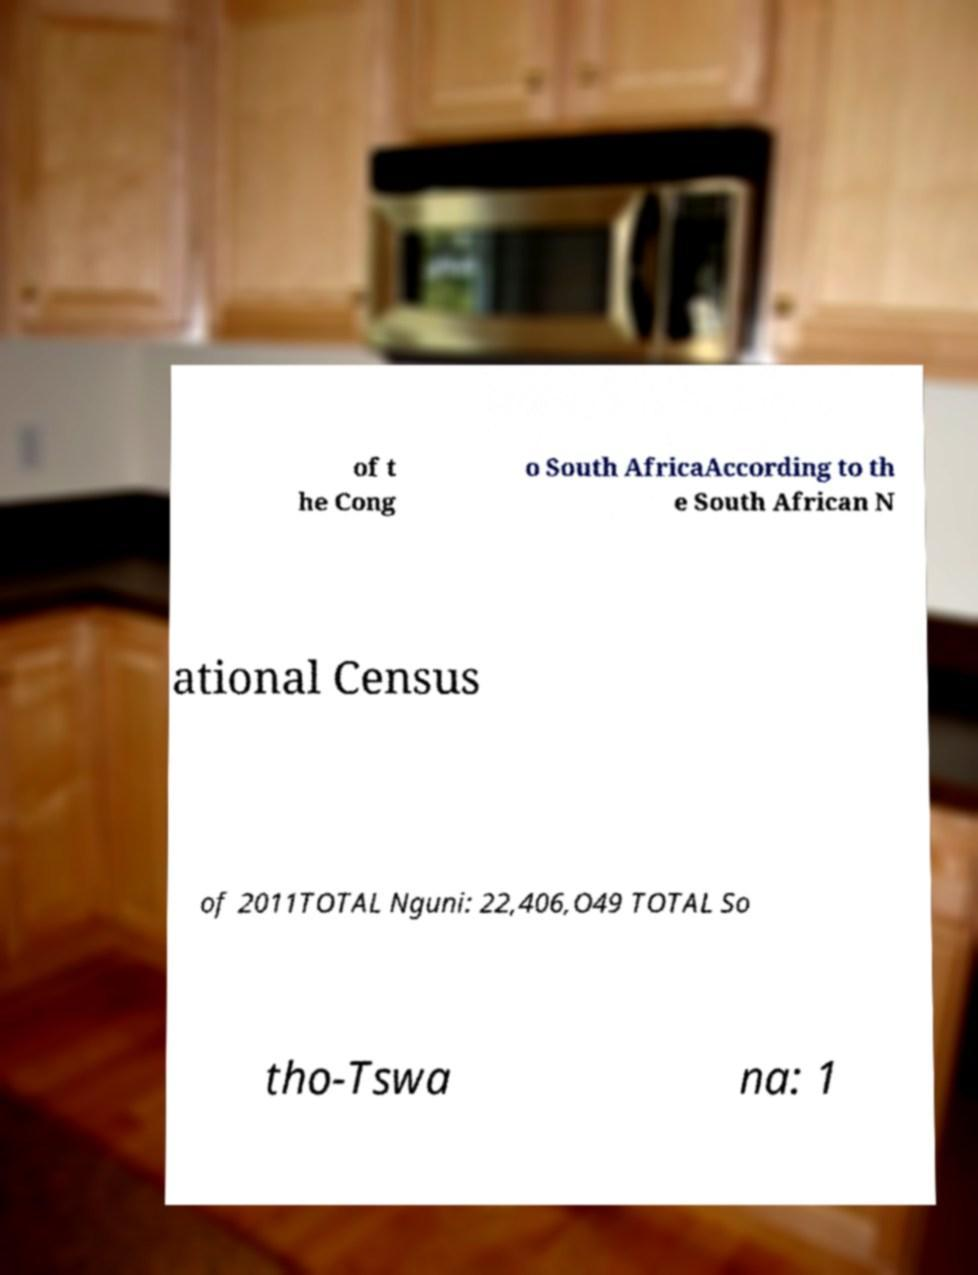I need the written content from this picture converted into text. Can you do that? of t he Cong o South AfricaAccording to th e South African N ational Census of 2011TOTAL Nguni: 22,406,O49 TOTAL So tho-Tswa na: 1 